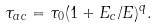<formula> <loc_0><loc_0><loc_500><loc_500>\tau _ { a c } = \tau _ { 0 } ( 1 + E _ { c } / E ) ^ { q } .</formula> 